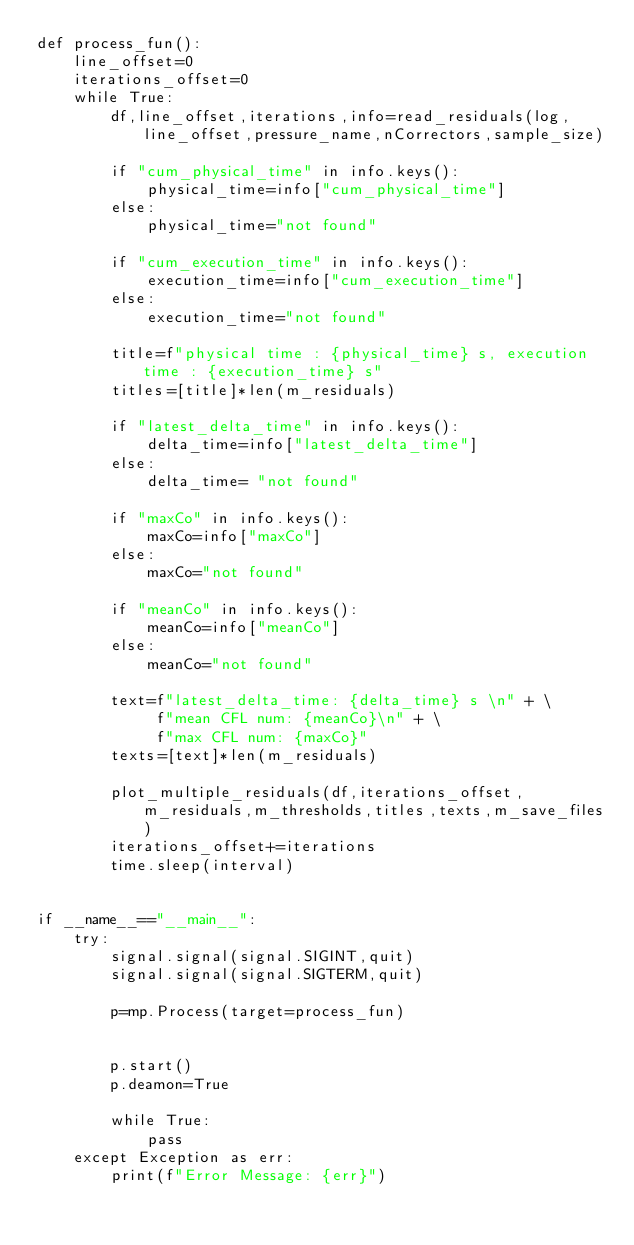Convert code to text. <code><loc_0><loc_0><loc_500><loc_500><_Python_>def process_fun():
    line_offset=0
    iterations_offset=0
    while True:
        df,line_offset,iterations,info=read_residuals(log,line_offset,pressure_name,nCorrectors,sample_size)
        
        if "cum_physical_time" in info.keys():
            physical_time=info["cum_physical_time"]
        else:
            physical_time="not found"

        if "cum_execution_time" in info.keys():
            execution_time=info["cum_execution_time"]
        else:
            execution_time="not found"

        title=f"physical time : {physical_time} s, execution time : {execution_time} s"
        titles=[title]*len(m_residuals)
        
        if "latest_delta_time" in info.keys():
            delta_time=info["latest_delta_time"]
        else:
            delta_time= "not found"

        if "maxCo" in info.keys():
            maxCo=info["maxCo"]
        else:
            maxCo="not found"
        
        if "meanCo" in info.keys():
            meanCo=info["meanCo"]
        else:
            meanCo="not found"
        
        text=f"latest_delta_time: {delta_time} s \n" + \
             f"mean CFL num: {meanCo}\n" + \
             f"max CFL num: {maxCo}"
        texts=[text]*len(m_residuals)
        
        plot_multiple_residuals(df,iterations_offset,m_residuals,m_thresholds,titles,texts,m_save_files)
        iterations_offset+=iterations
        time.sleep(interval)


if __name__=="__main__":
    try:
        signal.signal(signal.SIGINT,quit)
        signal.signal(signal.SIGTERM,quit)

        p=mp.Process(target=process_fun)

        
        p.start()
        p.deamon=True
        
        while True:
            pass
    except Exception as err:
        print(f"Error Message: {err}")

</code> 